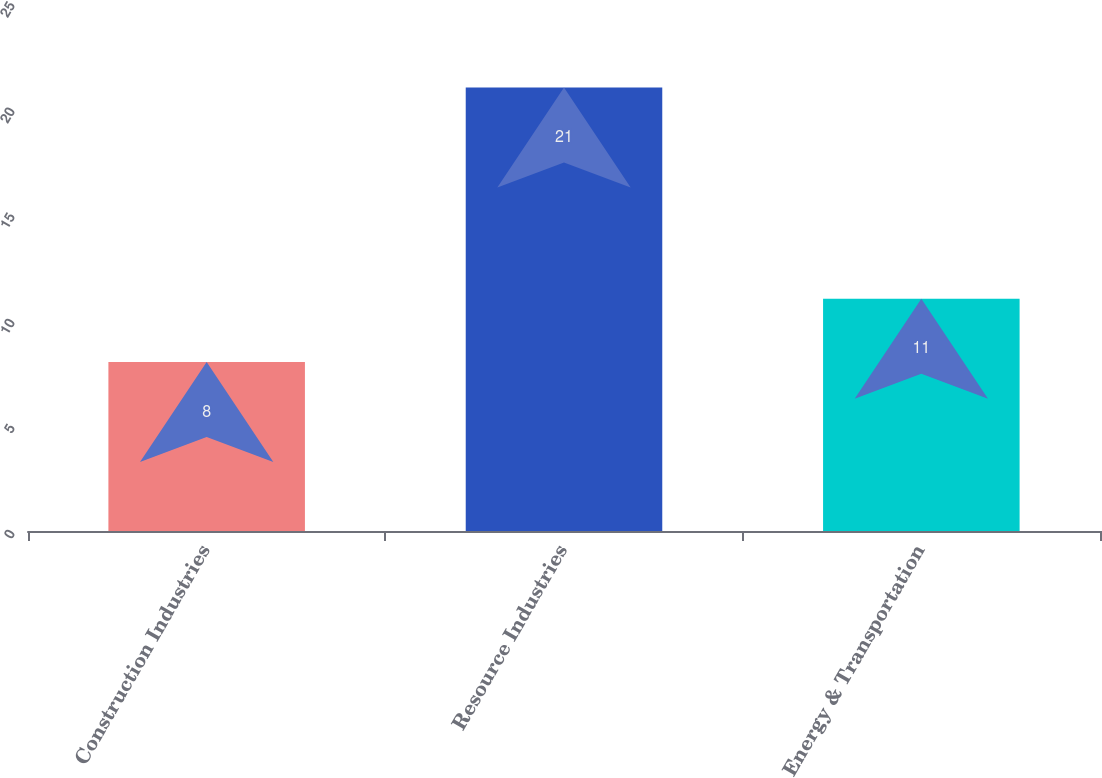Convert chart. <chart><loc_0><loc_0><loc_500><loc_500><bar_chart><fcel>Construction Industries<fcel>Resource Industries<fcel>Energy & Transportation<nl><fcel>8<fcel>21<fcel>11<nl></chart> 